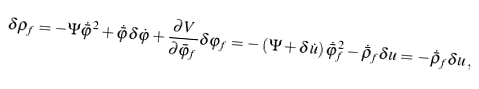Convert formula to latex. <formula><loc_0><loc_0><loc_500><loc_500>\delta \rho _ { f } = - \Psi \dot { \bar { \varphi } } ^ { 2 } + \dot { \bar { \varphi } } \delta \dot { \varphi } + \frac { \partial V } { \partial \bar { \varphi } _ { f } } \delta \varphi _ { f } = - \left ( \Psi + \delta \dot { u } \right ) \dot { \bar { \varphi } } _ { f } ^ { 2 } - \dot { \bar { \rho } } _ { f } \delta u = - \dot { \bar { \rho } } _ { f } \delta u \, ,</formula> 